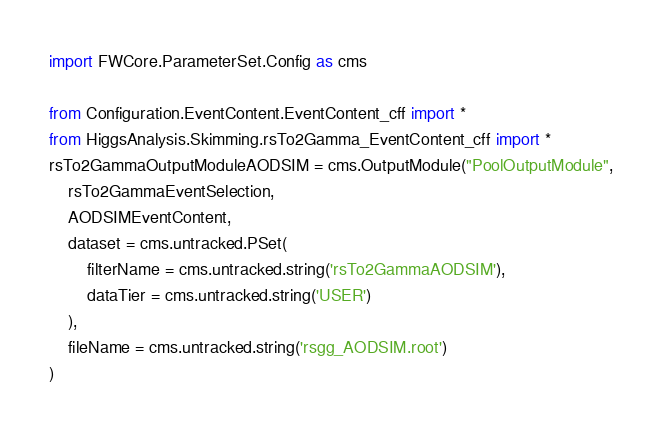Convert code to text. <code><loc_0><loc_0><loc_500><loc_500><_Python_>import FWCore.ParameterSet.Config as cms

from Configuration.EventContent.EventContent_cff import *
from HiggsAnalysis.Skimming.rsTo2Gamma_EventContent_cff import *
rsTo2GammaOutputModuleAODSIM = cms.OutputModule("PoolOutputModule",
    rsTo2GammaEventSelection,
    AODSIMEventContent,
    dataset = cms.untracked.PSet(
        filterName = cms.untracked.string('rsTo2GammaAODSIM'),
        dataTier = cms.untracked.string('USER')
    ),
    fileName = cms.untracked.string('rsgg_AODSIM.root')
)


</code> 